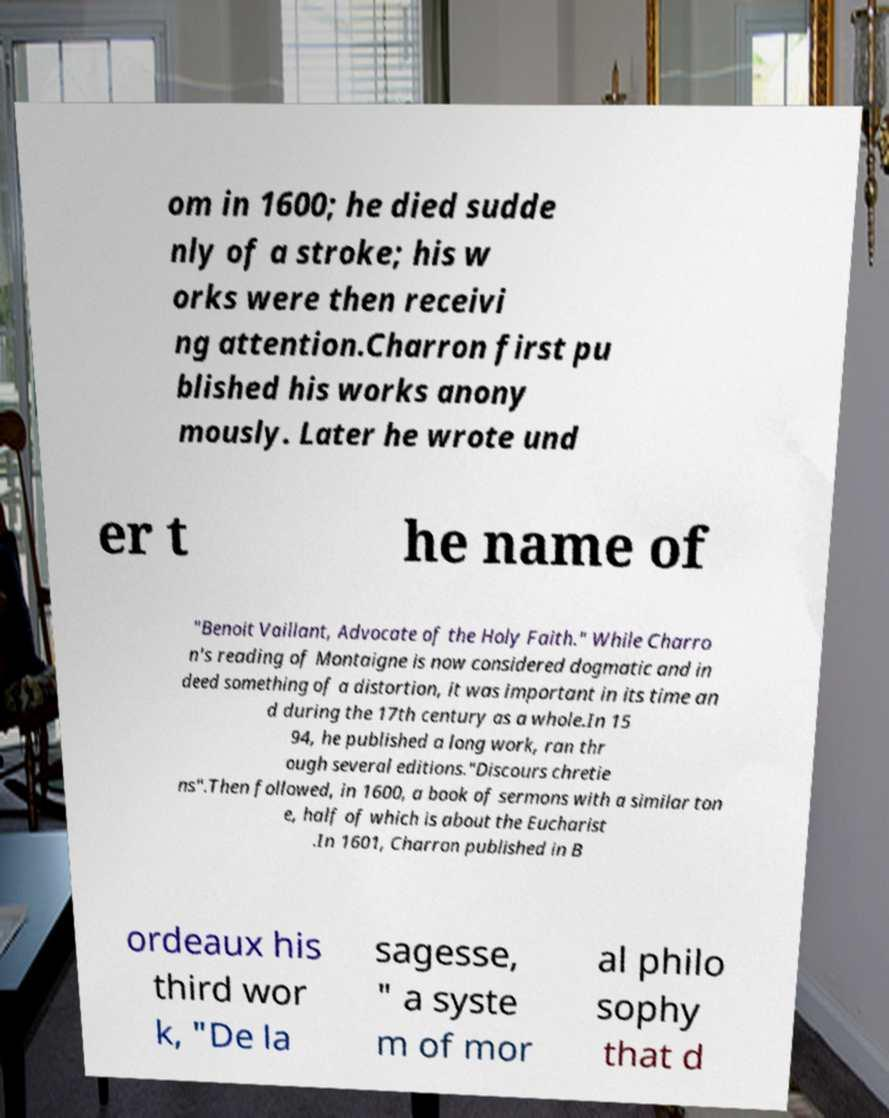Could you assist in decoding the text presented in this image and type it out clearly? om in 1600; he died sudde nly of a stroke; his w orks were then receivi ng attention.Charron first pu blished his works anony mously. Later he wrote und er t he name of "Benoit Vaillant, Advocate of the Holy Faith." While Charro n's reading of Montaigne is now considered dogmatic and in deed something of a distortion, it was important in its time an d during the 17th century as a whole.In 15 94, he published a long work, ran thr ough several editions."Discours chretie ns".Then followed, in 1600, a book of sermons with a similar ton e, half of which is about the Eucharist .In 1601, Charron published in B ordeaux his third wor k, "De la sagesse, " a syste m of mor al philo sophy that d 